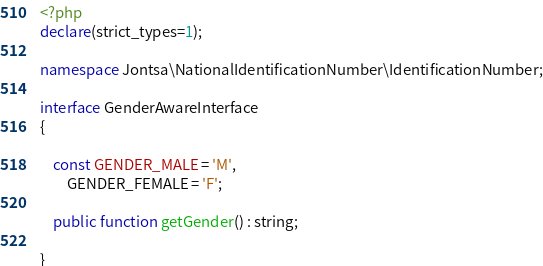<code> <loc_0><loc_0><loc_500><loc_500><_PHP_><?php
declare(strict_types=1);

namespace Jontsa\NationalIdentificationNumber\IdentificationNumber;

interface GenderAwareInterface
{

    const GENDER_MALE = 'M',
        GENDER_FEMALE = 'F';

    public function getGender() : string;

}
</code> 